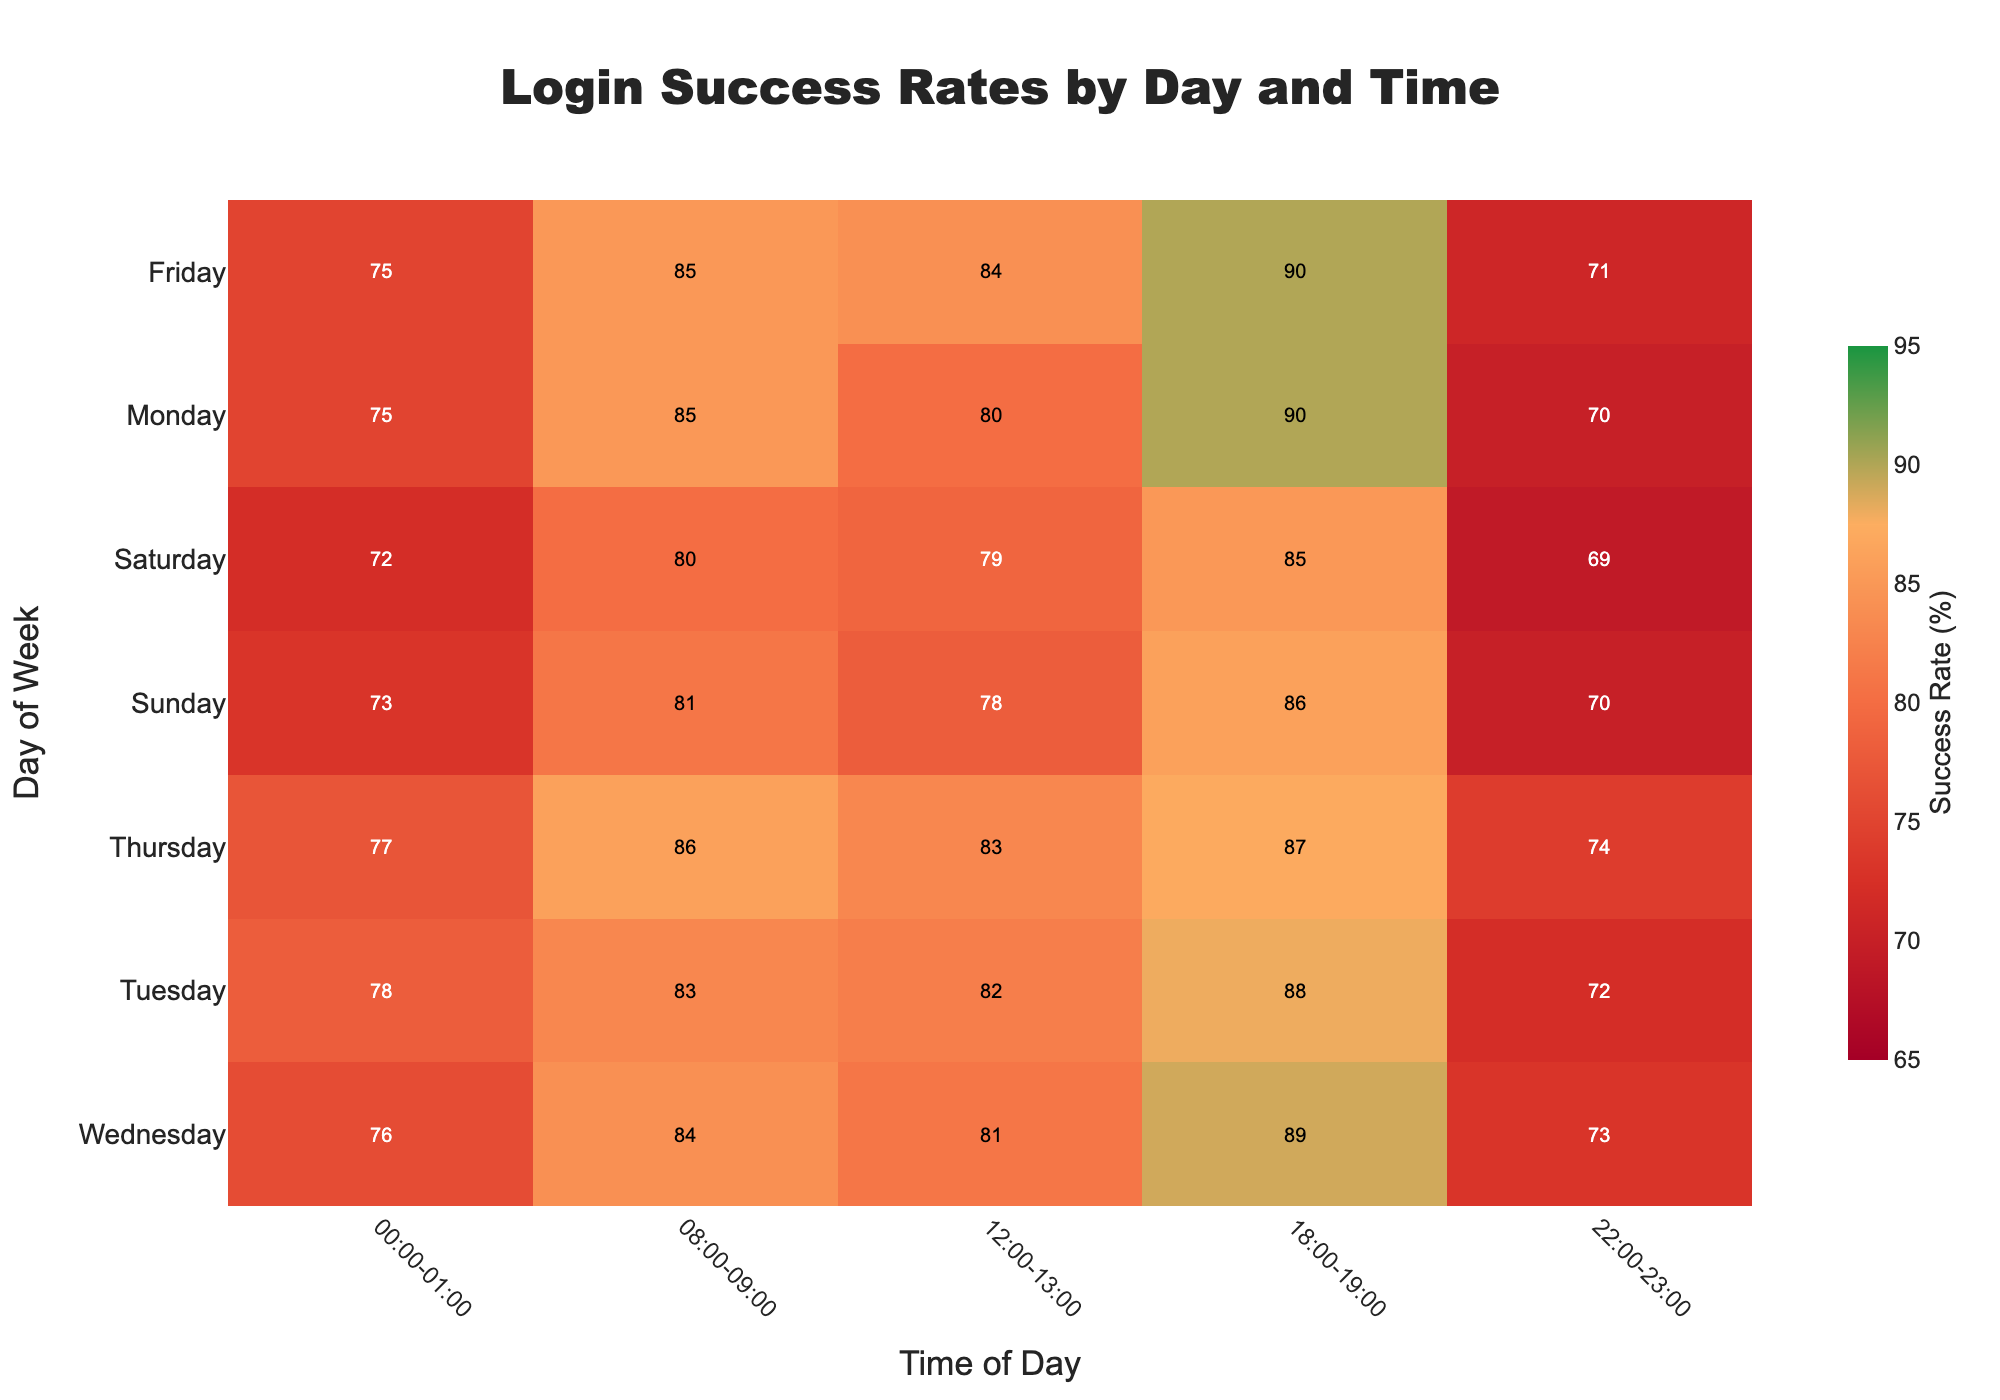What is the title of the heatmap? The title is often displayed at the top of the heatmap. In this instance, it is set directly in the plot.
Answer: Login Success Rates by Day and Time Which time slot on Monday has the highest login success rate? Look at the color that indicates the highest value for Monday, on the y-axis, and the corresponding time slot on the x-axis. Check the annotation for the highest number.
Answer: 18:00-19:00 What is the overall trend of login success rates from Monday to Sunday during 18:00-19:00? Look at the colors for the time slot 18:00-19:00 across all days from Monday to Sunday. The trend can be inferred from the changing colors and values, starting from darker to lighter colors or vice versa.
Answer: Generally high with values ranging from 85 to 90% On which day and time slot is the login success rate exactly 70%? Look at the annotations on the heatmap and find the cell(s) annotated with 70%. Then check the corresponding day and time slot.
Answer: Monday at 22:00-23:00 and Sunday at 22:00-23:00 How do the login success rates compare between Monday 08:00-09:00 and Wednesday 08:00-09:00? Find the values for Monday and Wednesday in the 08:00-09:00 time slot from their annotations. Compare the two values directly.
Answer: 85% on Monday and 84% on Wednesday What is the average login success rate for Thursday? Obtain the success rates for Thursday across all time slots and calculate their average. Values: [77, 86, 83, 87, 74]. (77+86+83+87+74)/5 = 81.4%
Answer: 81.4% Is there any time slot where the login success rate always stays above 80% throughout the week? Check the annotations of each time slot from Monday to Sunday and observe if all values are above 80% for any specific time slot. If all values in a time slot are above 80, that meets the condition.
Answer: 18:00-19:00 What is the login success rate at 00:00-01:00 on Friday? How does it compare to the same time on Wednesday? Find and compare the values for 00:00-01:00 on Friday and Wednesday via their annotations.
Answer: 75% on Friday, 76% on Wednesday Which day has the lowest login success rate at 08:00-09:00? Look at the values for the time slot 08:00-09:00 across all days. Identify the lowest annotation value.
Answer: Saturday, with 80% How does the login success rate at 12:00-13:00 on Sunday compare to Saturday? Locate the value for 12:00-13:00 on Sunday and Saturday from their annotations and compare them.
Answer: 78% on Sunday, 79% on Saturday 